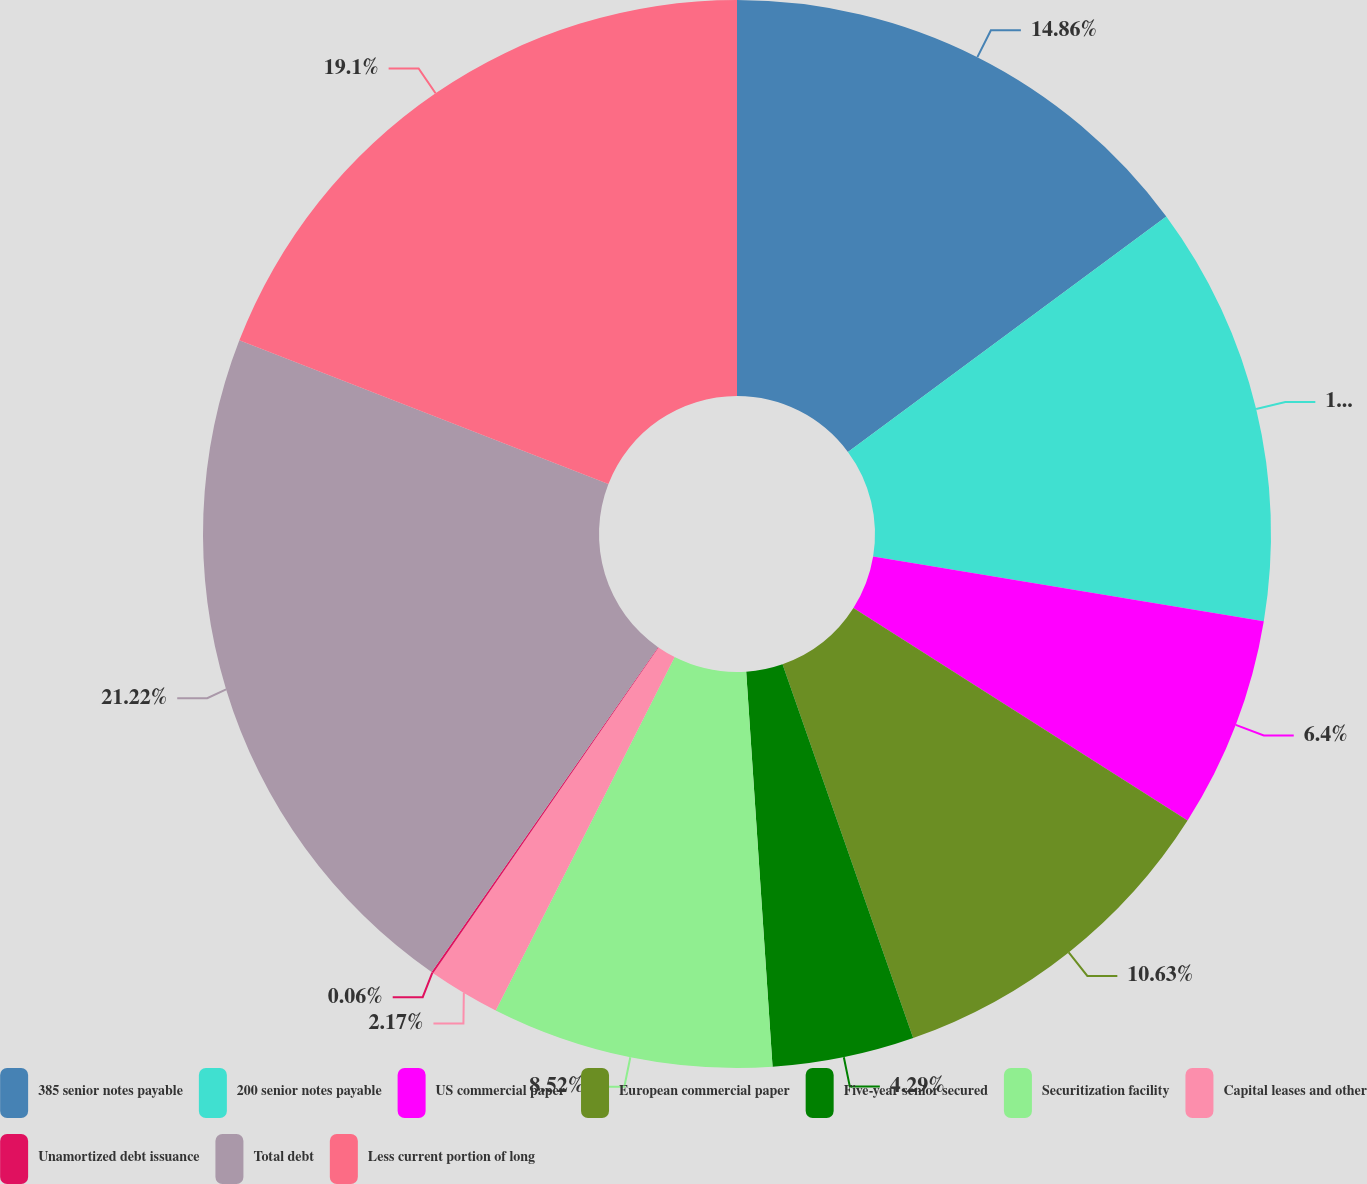Convert chart to OTSL. <chart><loc_0><loc_0><loc_500><loc_500><pie_chart><fcel>385 senior notes payable<fcel>200 senior notes payable<fcel>US commercial paper<fcel>European commercial paper<fcel>Five-year senior secured<fcel>Securitization facility<fcel>Capital leases and other<fcel>Unamortized debt issuance<fcel>Total debt<fcel>Less current portion of long<nl><fcel>14.86%<fcel>12.75%<fcel>6.4%<fcel>10.63%<fcel>4.29%<fcel>8.52%<fcel>2.17%<fcel>0.06%<fcel>21.21%<fcel>19.09%<nl></chart> 